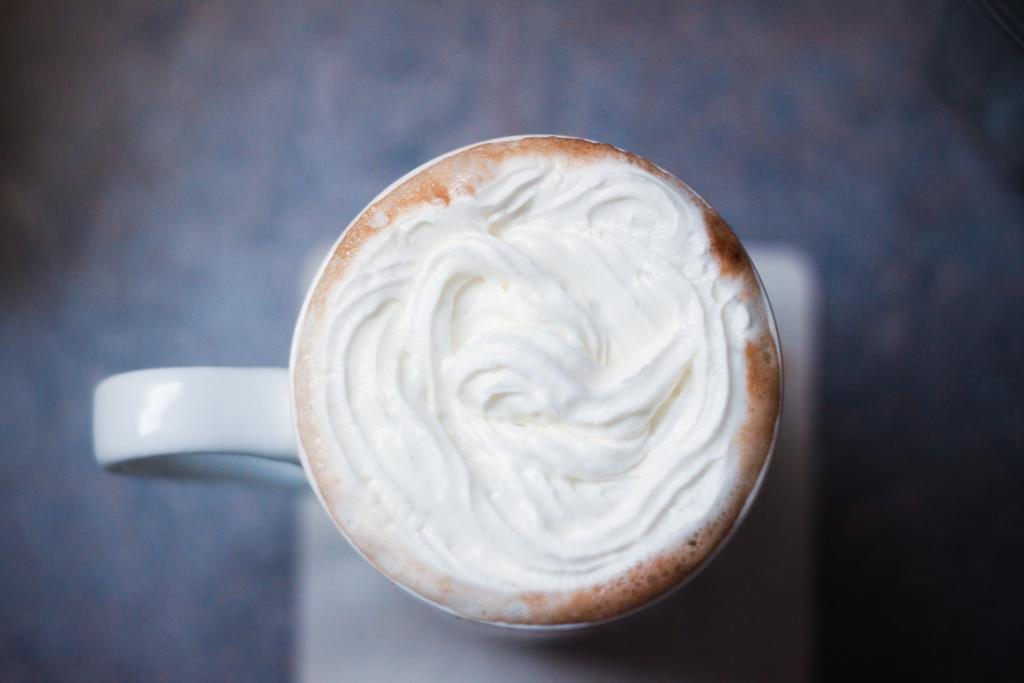What is in the cup that is visible in the image? There is a coffee cup in the image. What is inside the coffee cup? The coffee cup contains coffee. What is a unique feature of the coffee in the image? There is coffee art in the coffee. What color is the background of the image? The background of the image is blue. How is the background of the image depicted? The background is blurred. What type of collar can be seen on the goat in the image? There is no goat or collar present in the image. Is there any gold jewelry visible on the person in the image? There is no person or gold jewelry present in the image. 